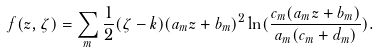Convert formula to latex. <formula><loc_0><loc_0><loc_500><loc_500>f ( z , \zeta ) = \sum _ { m } \frac { 1 } { 2 } ( \zeta - k ) ( a _ { m } z + b _ { m } ) ^ { 2 } \ln ( \frac { c _ { m } ( a _ { m } z + b _ { m } ) } { a _ { m } ( c _ { m } + d _ { m } ) } ) .</formula> 